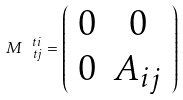Convert formula to latex. <formula><loc_0><loc_0><loc_500><loc_500>M ^ { \ t i } _ { \, \ t j } = \left ( \begin{array} { c c } 0 & 0 \\ 0 & A _ { i j } \end{array} \right )</formula> 